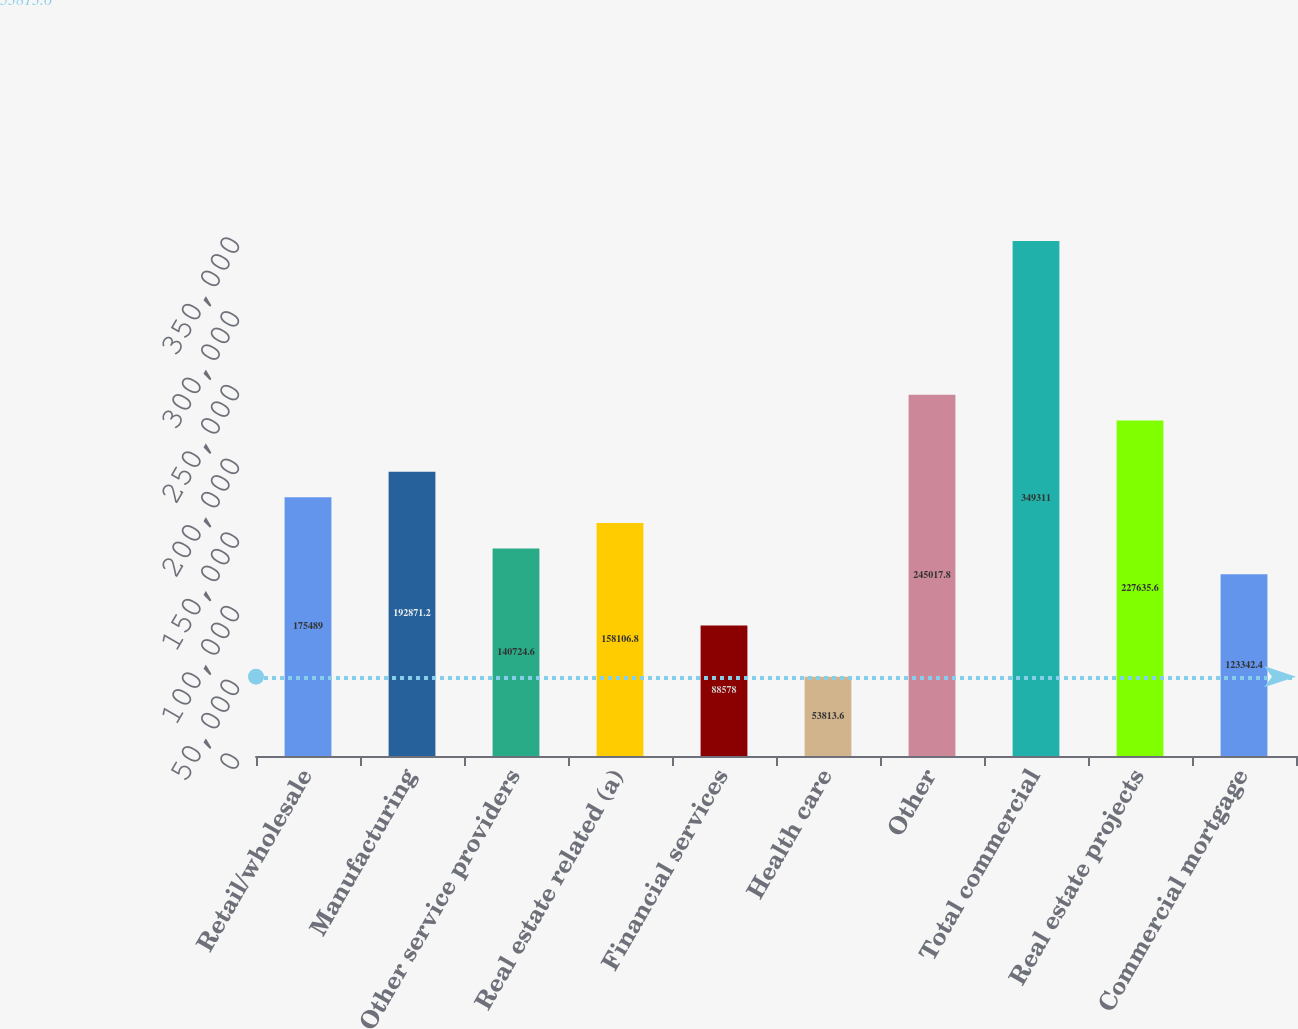<chart> <loc_0><loc_0><loc_500><loc_500><bar_chart><fcel>Retail/wholesale<fcel>Manufacturing<fcel>Other service providers<fcel>Real estate related (a)<fcel>Financial services<fcel>Health care<fcel>Other<fcel>Total commercial<fcel>Real estate projects<fcel>Commercial mortgage<nl><fcel>175489<fcel>192871<fcel>140725<fcel>158107<fcel>88578<fcel>53813.6<fcel>245018<fcel>349311<fcel>227636<fcel>123342<nl></chart> 